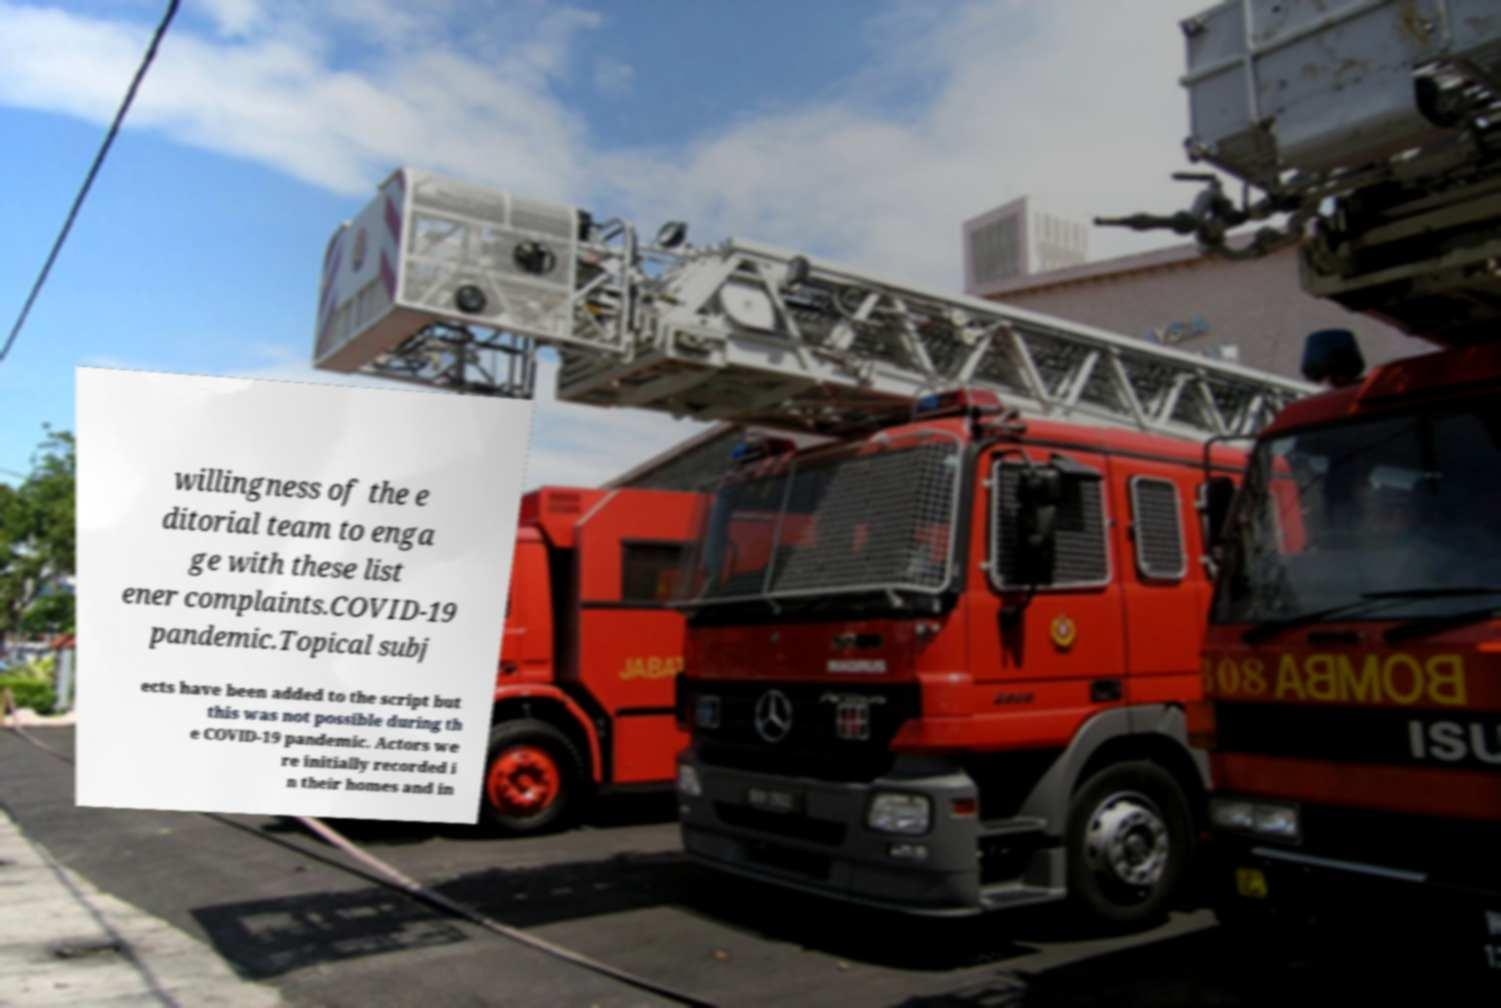What messages or text are displayed in this image? I need them in a readable, typed format. willingness of the e ditorial team to enga ge with these list ener complaints.COVID-19 pandemic.Topical subj ects have been added to the script but this was not possible during th e COVID-19 pandemic. Actors we re initially recorded i n their homes and in 